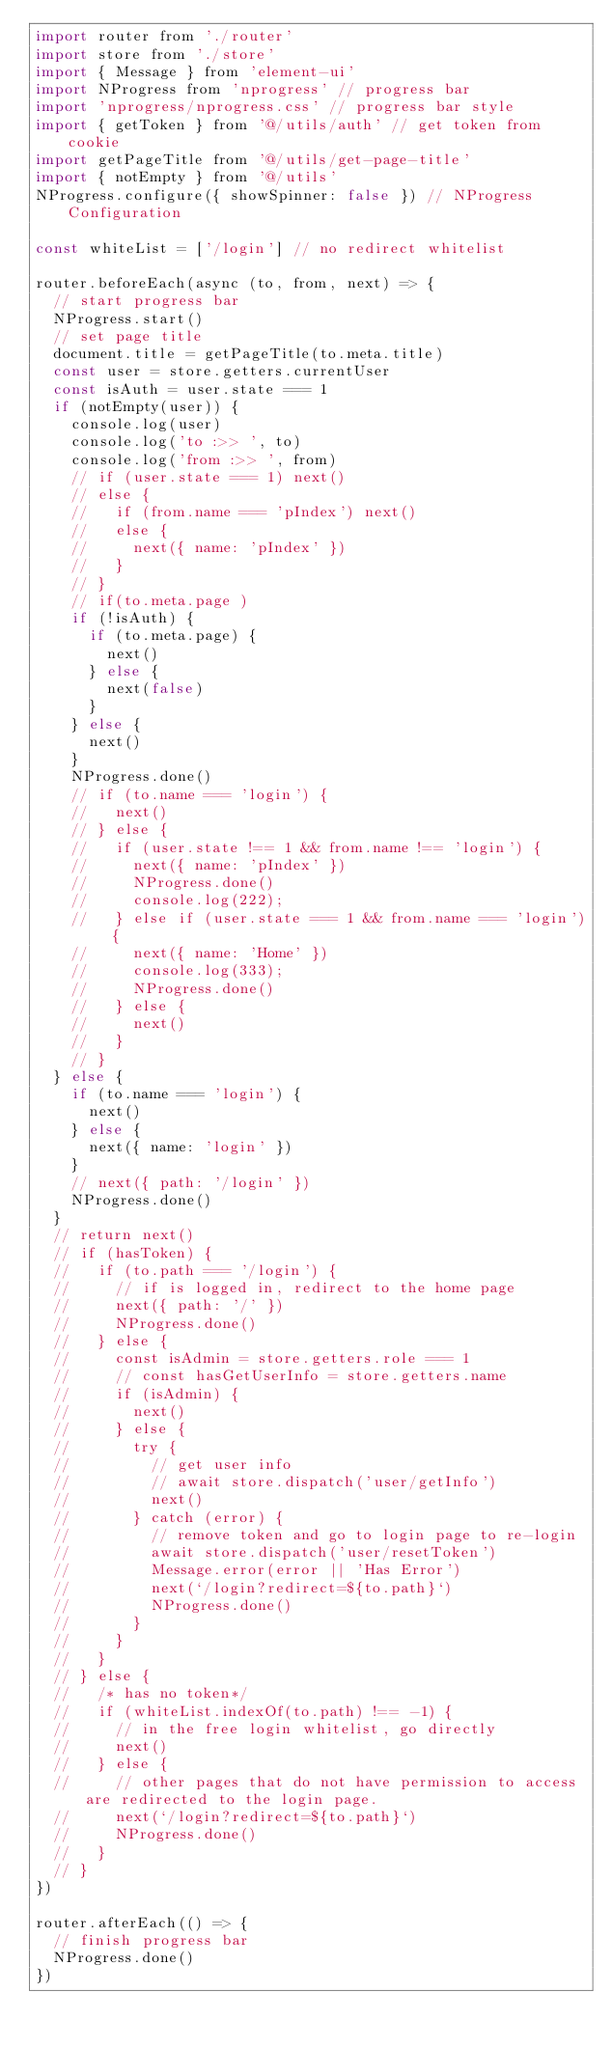Convert code to text. <code><loc_0><loc_0><loc_500><loc_500><_JavaScript_>import router from './router'
import store from './store'
import { Message } from 'element-ui'
import NProgress from 'nprogress' // progress bar
import 'nprogress/nprogress.css' // progress bar style
import { getToken } from '@/utils/auth' // get token from cookie
import getPageTitle from '@/utils/get-page-title'
import { notEmpty } from '@/utils'
NProgress.configure({ showSpinner: false }) // NProgress Configuration

const whiteList = ['/login'] // no redirect whitelist

router.beforeEach(async (to, from, next) => {
  // start progress bar
  NProgress.start()
  // set page title
  document.title = getPageTitle(to.meta.title)
  const user = store.getters.currentUser
  const isAuth = user.state === 1
  if (notEmpty(user)) {
    console.log(user)
    console.log('to :>> ', to)
    console.log('from :>> ', from)
    // if (user.state === 1) next()
    // else {
    //   if (from.name === 'pIndex') next()
    //   else {
    //     next({ name: 'pIndex' })
    //   }
    // }
    // if(to.meta.page )
    if (!isAuth) {
      if (to.meta.page) {
        next()
      } else {
        next(false)
      }
    } else {
      next()
    }
    NProgress.done()
    // if (to.name === 'login') {
    //   next()
    // } else {
    //   if (user.state !== 1 && from.name !== 'login') {
    //     next({ name: 'pIndex' })
    //     NProgress.done()
    //     console.log(222);
    //   } else if (user.state === 1 && from.name === 'login') {
    //     next({ name: 'Home' })
    //     console.log(333);
    //     NProgress.done()
    //   } else {
    //     next()
    //   }
    // }
  } else {
    if (to.name === 'login') {
      next()
    } else {
      next({ name: 'login' })
    }
    // next({ path: '/login' })
    NProgress.done()
  }
  // return next()
  // if (hasToken) {
  //   if (to.path === '/login') {
  //     // if is logged in, redirect to the home page
  //     next({ path: '/' })
  //     NProgress.done()
  //   } else {
  //     const isAdmin = store.getters.role === 1
  //     // const hasGetUserInfo = store.getters.name
  //     if (isAdmin) {
  //       next()
  //     } else {
  //       try {
  //         // get user info
  //         // await store.dispatch('user/getInfo')
  //         next()
  //       } catch (error) {
  //         // remove token and go to login page to re-login
  //         await store.dispatch('user/resetToken')
  //         Message.error(error || 'Has Error')
  //         next(`/login?redirect=${to.path}`)
  //         NProgress.done()
  //       }
  //     }
  //   }
  // } else {
  //   /* has no token*/
  //   if (whiteList.indexOf(to.path) !== -1) {
  //     // in the free login whitelist, go directly
  //     next()
  //   } else {
  //     // other pages that do not have permission to access are redirected to the login page.
  //     next(`/login?redirect=${to.path}`)
  //     NProgress.done()
  //   }
  // }
})

router.afterEach(() => {
  // finish progress bar
  NProgress.done()
})
</code> 